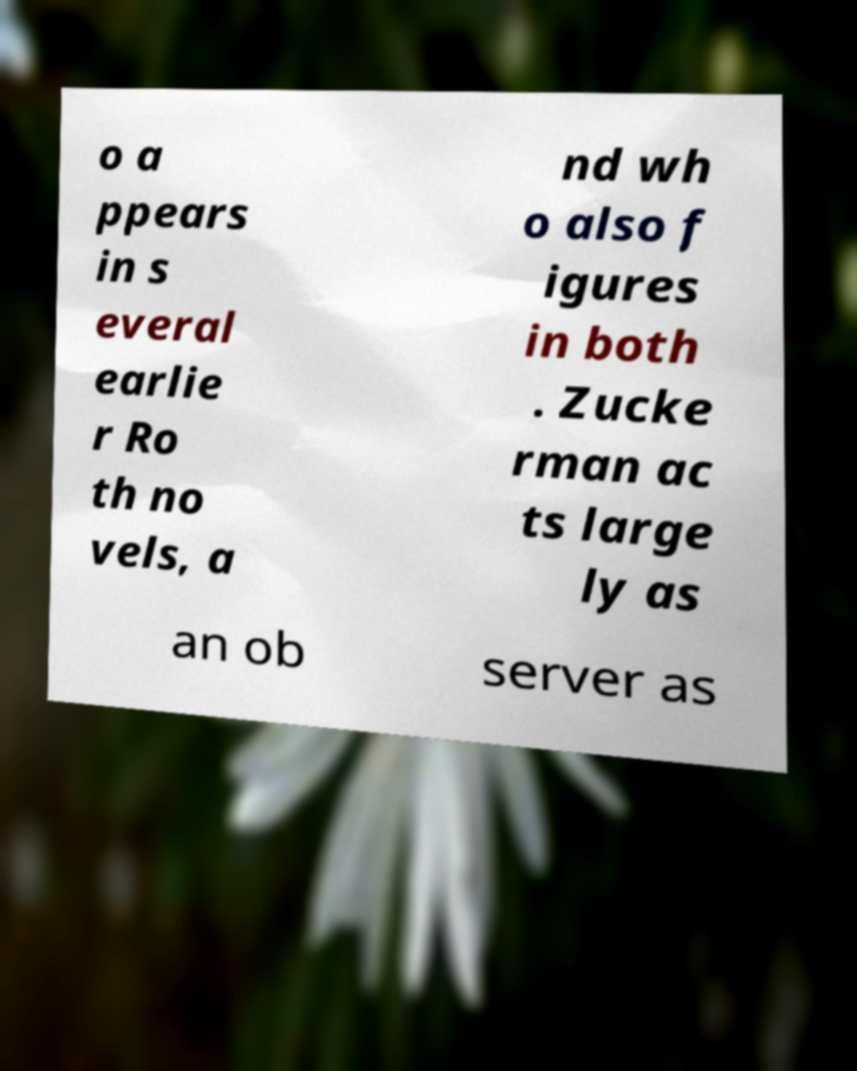Could you extract and type out the text from this image? o a ppears in s everal earlie r Ro th no vels, a nd wh o also f igures in both . Zucke rman ac ts large ly as an ob server as 